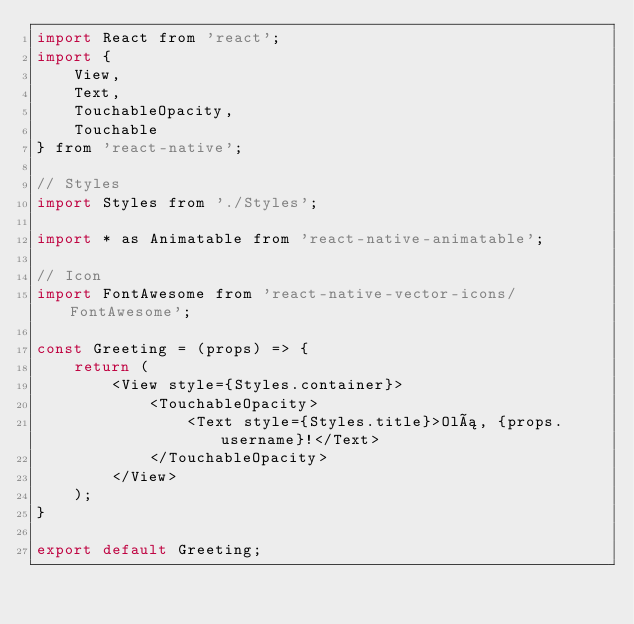Convert code to text. <code><loc_0><loc_0><loc_500><loc_500><_JavaScript_>import React from 'react';
import {
    View,
    Text,
    TouchableOpacity,
    Touchable
} from 'react-native';

// Styles
import Styles from './Styles';

import * as Animatable from 'react-native-animatable';

// Icon
import FontAwesome from 'react-native-vector-icons/FontAwesome';

const Greeting = (props) => {
    return (
        <View style={Styles.container}>
            <TouchableOpacity>
                <Text style={Styles.title}>Olá, {props.username}!</Text>
            </TouchableOpacity>
        </View>
    );
}

export default Greeting;</code> 